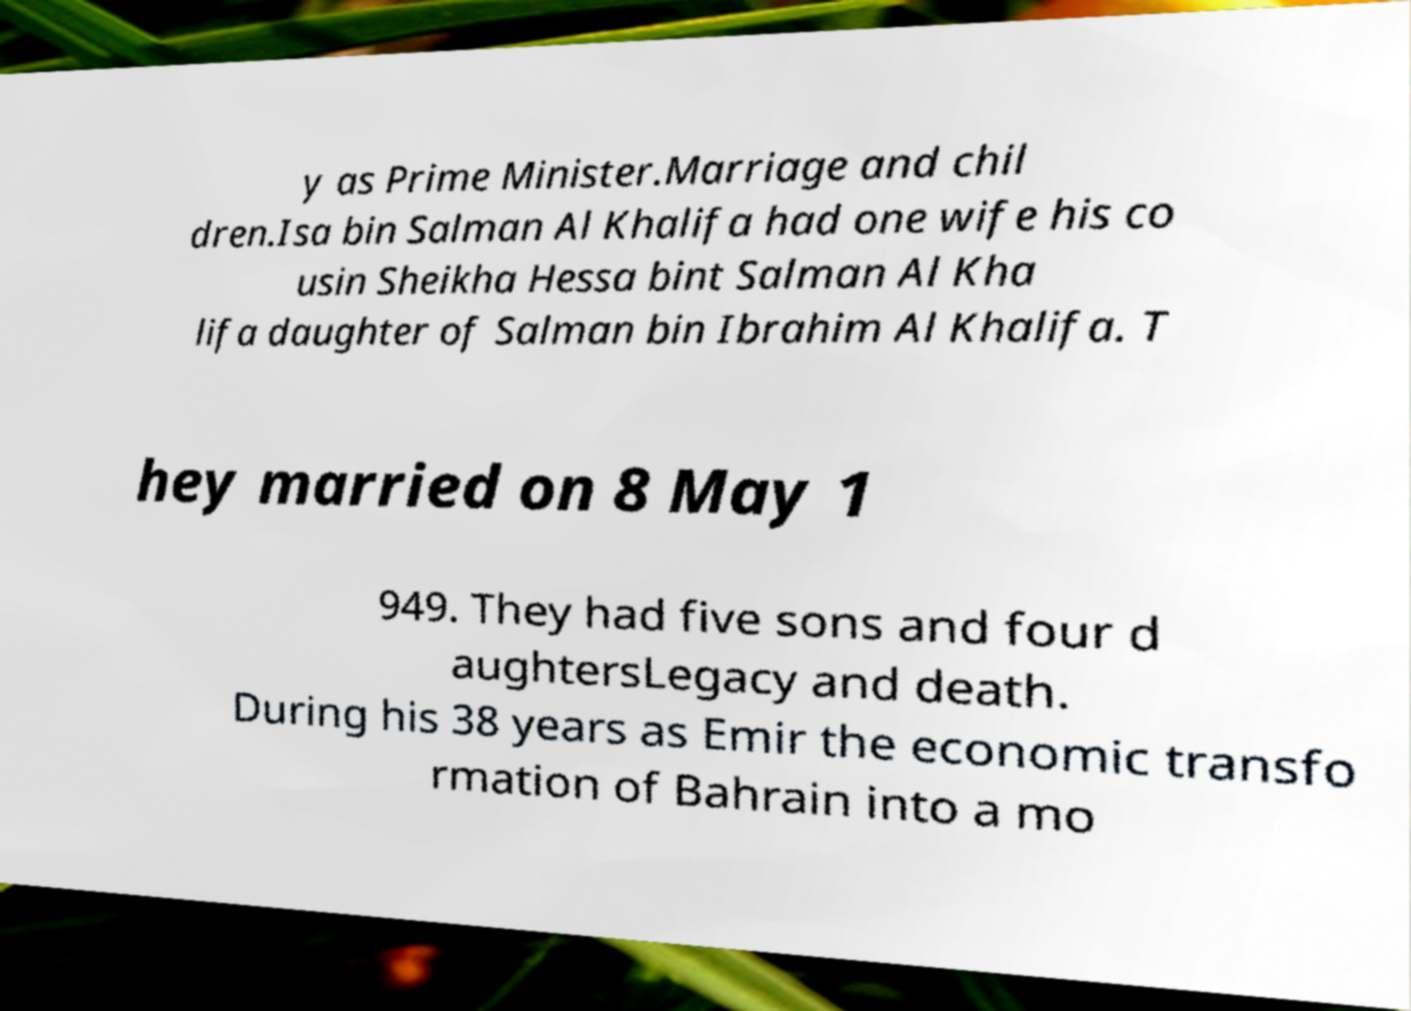What messages or text are displayed in this image? I need them in a readable, typed format. y as Prime Minister.Marriage and chil dren.Isa bin Salman Al Khalifa had one wife his co usin Sheikha Hessa bint Salman Al Kha lifa daughter of Salman bin Ibrahim Al Khalifa. T hey married on 8 May 1 949. They had five sons and four d aughtersLegacy and death. During his 38 years as Emir the economic transfo rmation of Bahrain into a mo 